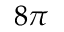Convert formula to latex. <formula><loc_0><loc_0><loc_500><loc_500>8 \pi</formula> 